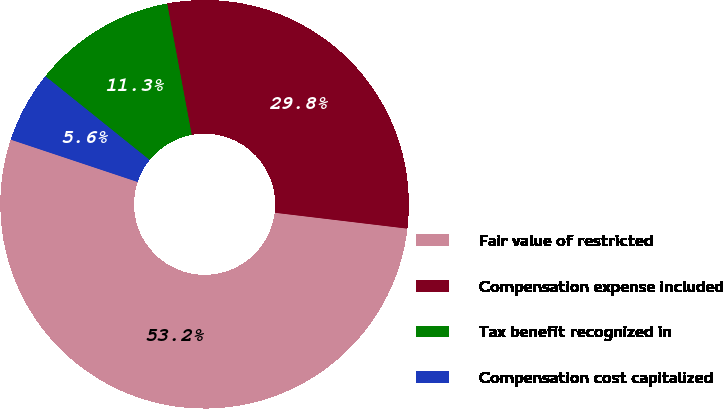Convert chart. <chart><loc_0><loc_0><loc_500><loc_500><pie_chart><fcel>Fair value of restricted<fcel>Compensation expense included<fcel>Tax benefit recognized in<fcel>Compensation cost capitalized<nl><fcel>53.23%<fcel>29.84%<fcel>11.29%<fcel>5.65%<nl></chart> 